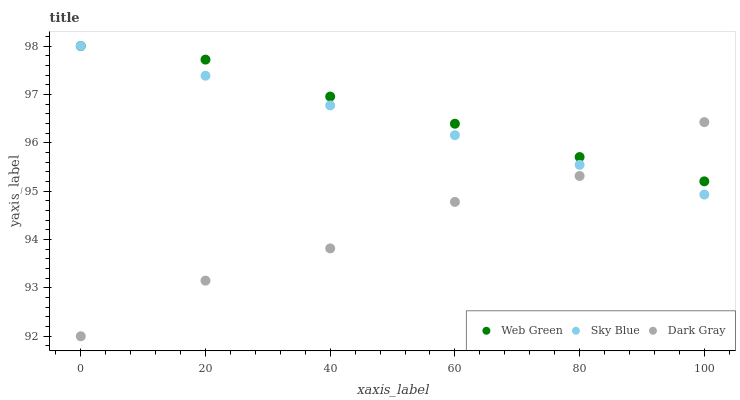Does Dark Gray have the minimum area under the curve?
Answer yes or no. Yes. Does Web Green have the maximum area under the curve?
Answer yes or no. Yes. Does Sky Blue have the minimum area under the curve?
Answer yes or no. No. Does Sky Blue have the maximum area under the curve?
Answer yes or no. No. Is Sky Blue the smoothest?
Answer yes or no. Yes. Is Dark Gray the roughest?
Answer yes or no. Yes. Is Web Green the smoothest?
Answer yes or no. No. Is Web Green the roughest?
Answer yes or no. No. Does Dark Gray have the lowest value?
Answer yes or no. Yes. Does Sky Blue have the lowest value?
Answer yes or no. No. Does Web Green have the highest value?
Answer yes or no. Yes. Does Sky Blue intersect Dark Gray?
Answer yes or no. Yes. Is Sky Blue less than Dark Gray?
Answer yes or no. No. Is Sky Blue greater than Dark Gray?
Answer yes or no. No. 